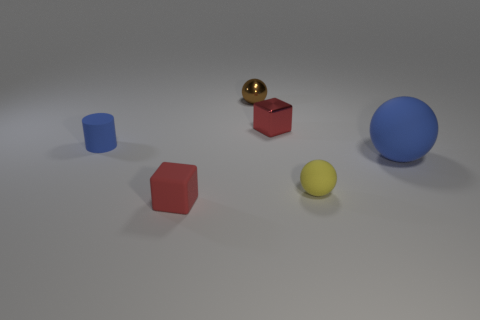How many balls are small rubber objects or yellow rubber things?
Your answer should be compact. 1. What color is the ball behind the tiny red block behind the blue rubber object that is to the left of the large blue rubber thing?
Ensure brevity in your answer.  Brown. How many other objects are there of the same size as the metal sphere?
Keep it short and to the point. 4. Is there any other thing that has the same shape as the tiny blue matte object?
Offer a terse response. No. The rubber object that is the same shape as the red shiny thing is what color?
Ensure brevity in your answer.  Red. There is another large thing that is made of the same material as the yellow thing; what color is it?
Give a very brief answer. Blue. Are there an equal number of large blue spheres that are behind the tiny blue thing and large brown balls?
Offer a very short reply. Yes. There is a blue object that is to the left of the matte block; does it have the same size as the brown ball?
Give a very brief answer. Yes. There is a shiny block that is the same size as the brown shiny object; what is its color?
Offer a very short reply. Red. Are there any big blue matte objects that are to the right of the blue matte object right of the small yellow matte thing behind the red matte object?
Your answer should be very brief. No. 